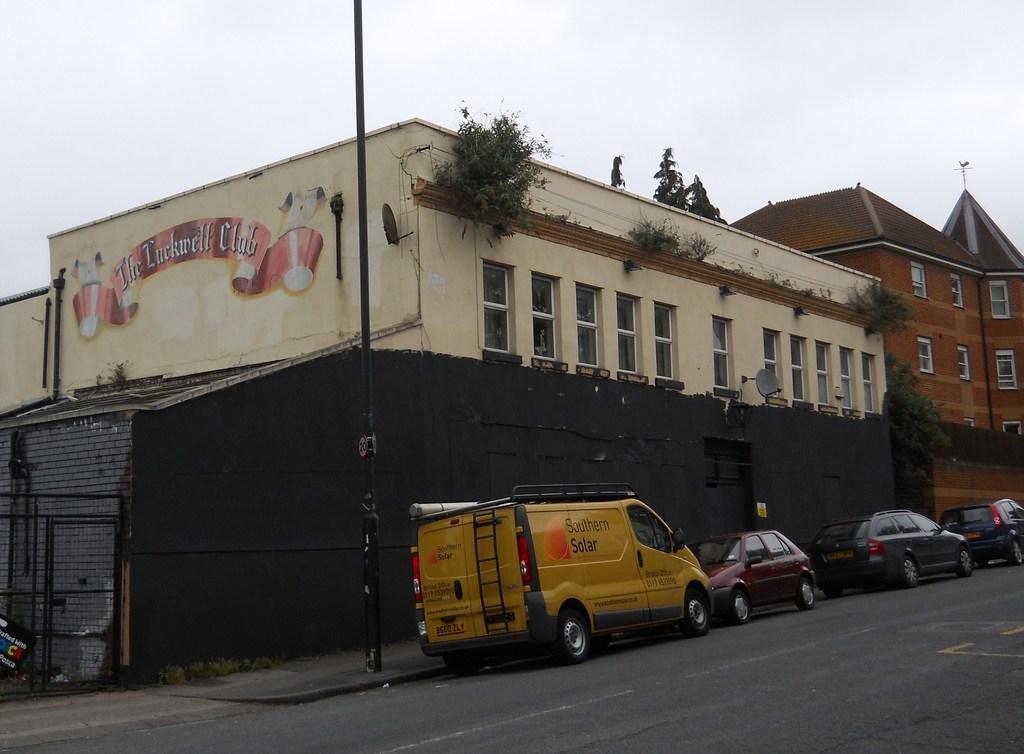How would you summarize this image in a sentence or two? In this image I can see the road. To the side of the road there are many vehicles and poles. To the side of the vehicles I can see the buildings and there are some bushes to the building. In the background I can see the sky. 